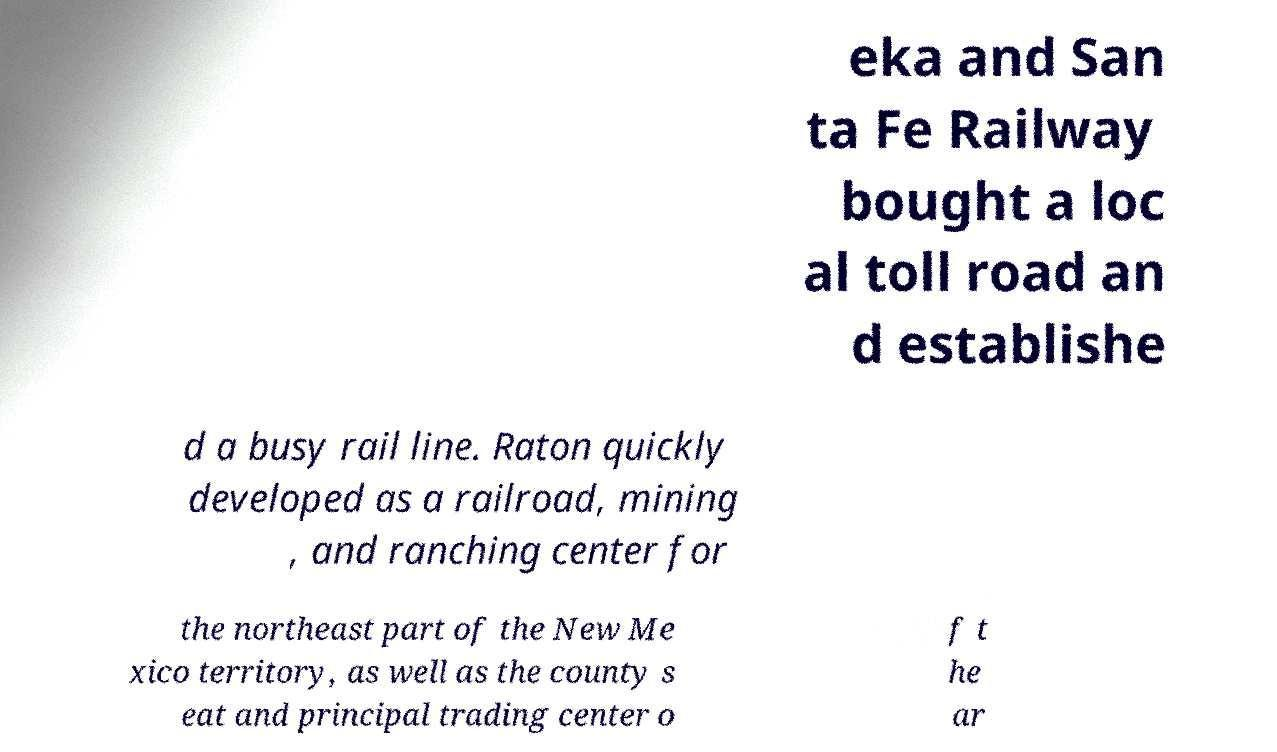Please read and relay the text visible in this image. What does it say? eka and San ta Fe Railway bought a loc al toll road an d establishe d a busy rail line. Raton quickly developed as a railroad, mining , and ranching center for the northeast part of the New Me xico territory, as well as the county s eat and principal trading center o f t he ar 